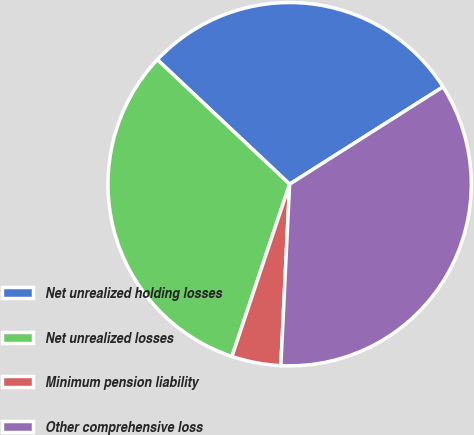<chart> <loc_0><loc_0><loc_500><loc_500><pie_chart><fcel>Net unrealized holding losses<fcel>Net unrealized losses<fcel>Minimum pension liability<fcel>Other comprehensive loss<nl><fcel>28.98%<fcel>31.88%<fcel>4.37%<fcel>34.77%<nl></chart> 